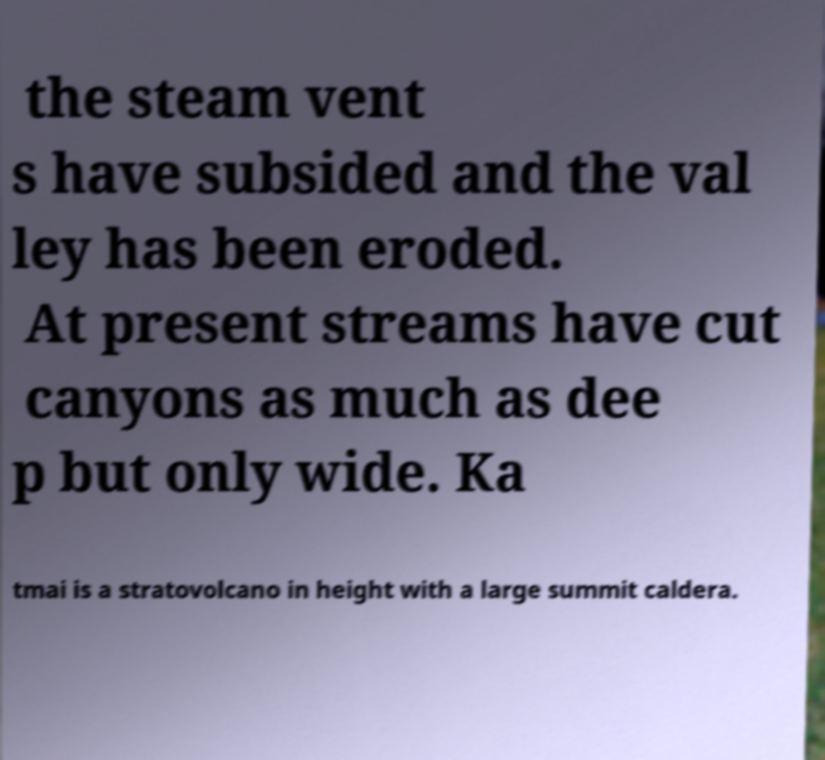What messages or text are displayed in this image? I need them in a readable, typed format. the steam vent s have subsided and the val ley has been eroded. At present streams have cut canyons as much as dee p but only wide. Ka tmai is a stratovolcano in height with a large summit caldera. 